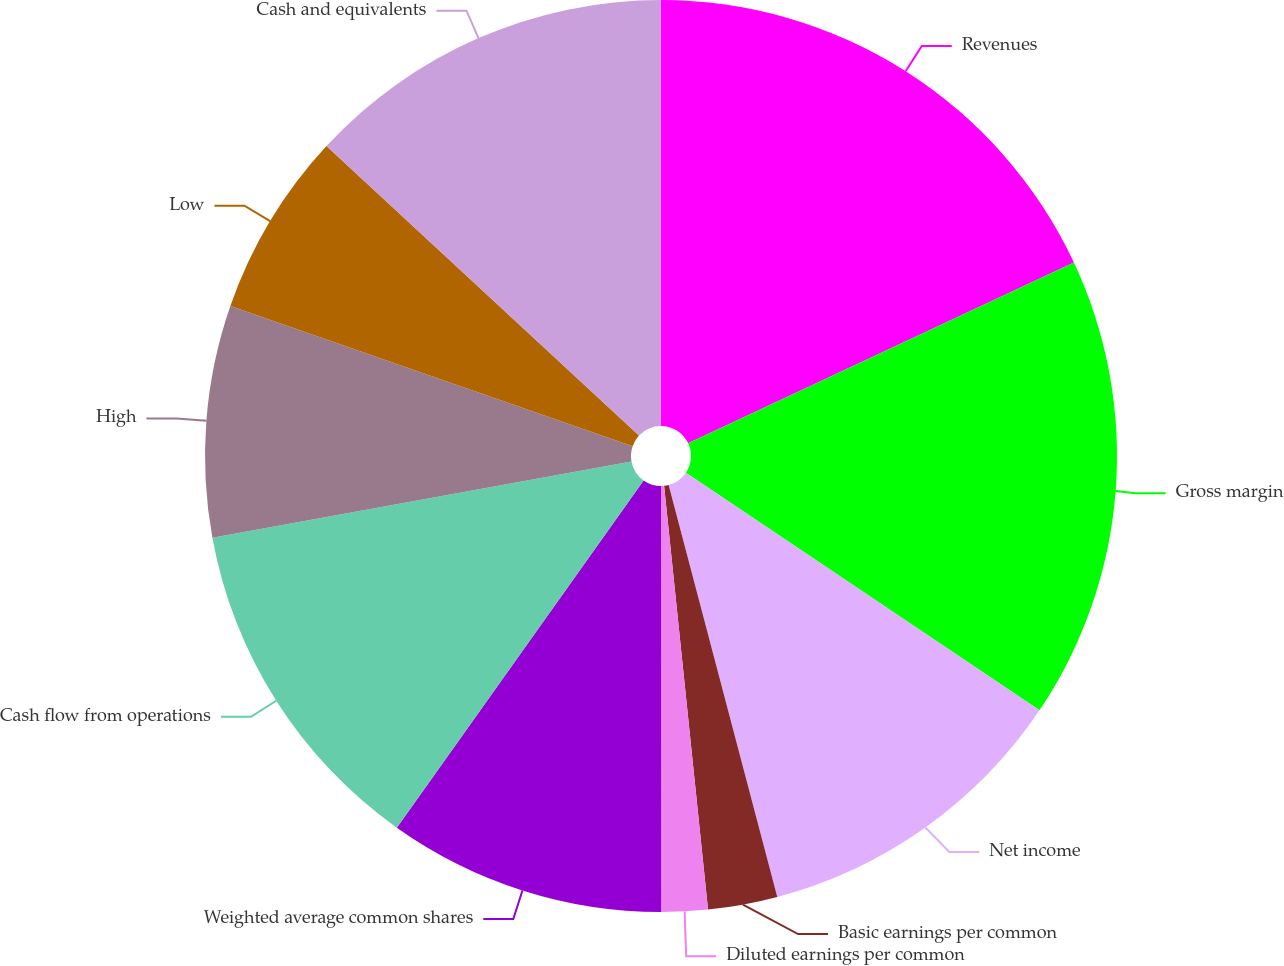Convert chart to OTSL. <chart><loc_0><loc_0><loc_500><loc_500><pie_chart><fcel>Revenues<fcel>Gross margin<fcel>Net income<fcel>Basic earnings per common<fcel>Diluted earnings per common<fcel>Weighted average common shares<fcel>Cash flow from operations<fcel>High<fcel>Low<fcel>Cash and equivalents<nl><fcel>18.03%<fcel>16.39%<fcel>11.48%<fcel>2.46%<fcel>1.64%<fcel>9.84%<fcel>12.3%<fcel>8.2%<fcel>6.56%<fcel>13.11%<nl></chart> 